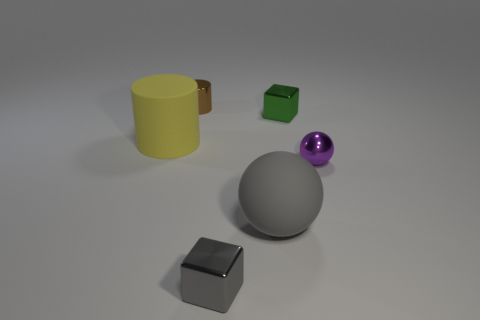What is the size of the metal thing on the right side of the cube behind the gray block?
Your answer should be very brief. Small. What number of objects are either purple metallic spheres or tiny yellow cylinders?
Offer a terse response. 1. Are there any tiny metal cylinders of the same color as the large matte sphere?
Give a very brief answer. No. Are there fewer tiny purple objects than small red cylinders?
Offer a very short reply. No. What number of things are large yellow things or small brown metallic objects that are on the left side of the tiny green cube?
Offer a terse response. 2. Is there a brown cylinder that has the same material as the big gray sphere?
Offer a terse response. No. What is the material of the cylinder that is the same size as the matte ball?
Make the answer very short. Rubber. What material is the small thing that is to the left of the metallic cube that is in front of the large matte cylinder made of?
Offer a terse response. Metal. There is a object in front of the large gray matte object; is its shape the same as the purple thing?
Make the answer very short. No. There is a cylinder that is the same material as the tiny sphere; what is its color?
Provide a short and direct response. Brown. 